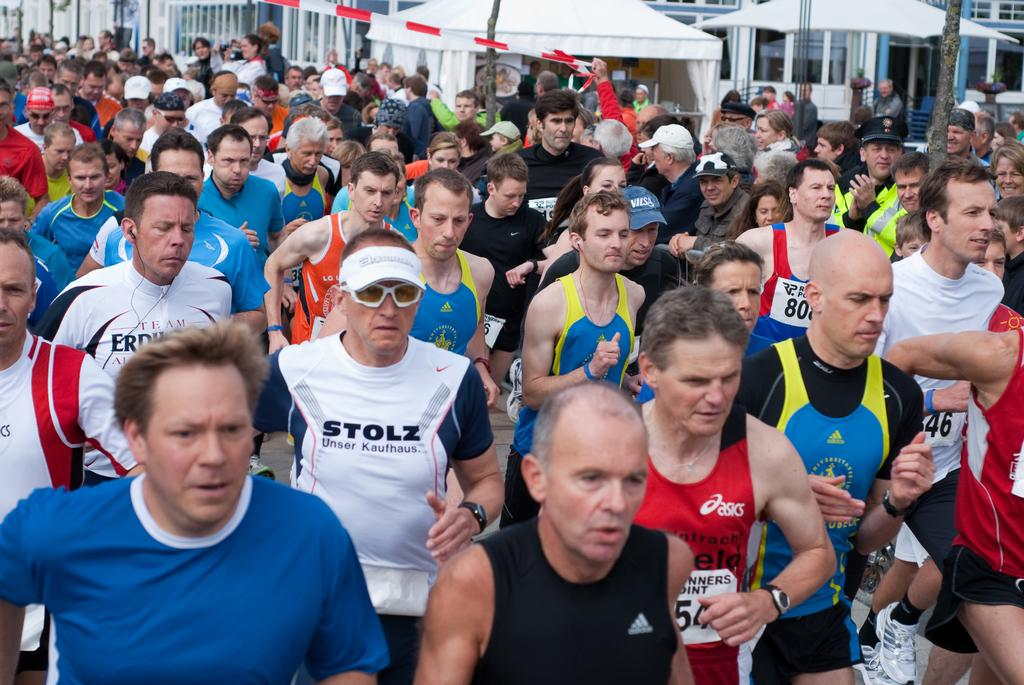What activity are the group of people engaged in? The group of people are participating in a running race. Are there any spectators present? Yes, there are people in the audience. What structure can be seen in the image? There is a tent and a building in the image. What record did the carpenter break during the race? There is no carpenter or record mentioned in the image. The image only shows a group of people participating in a running race, people in the audience, a tent, and a building. 